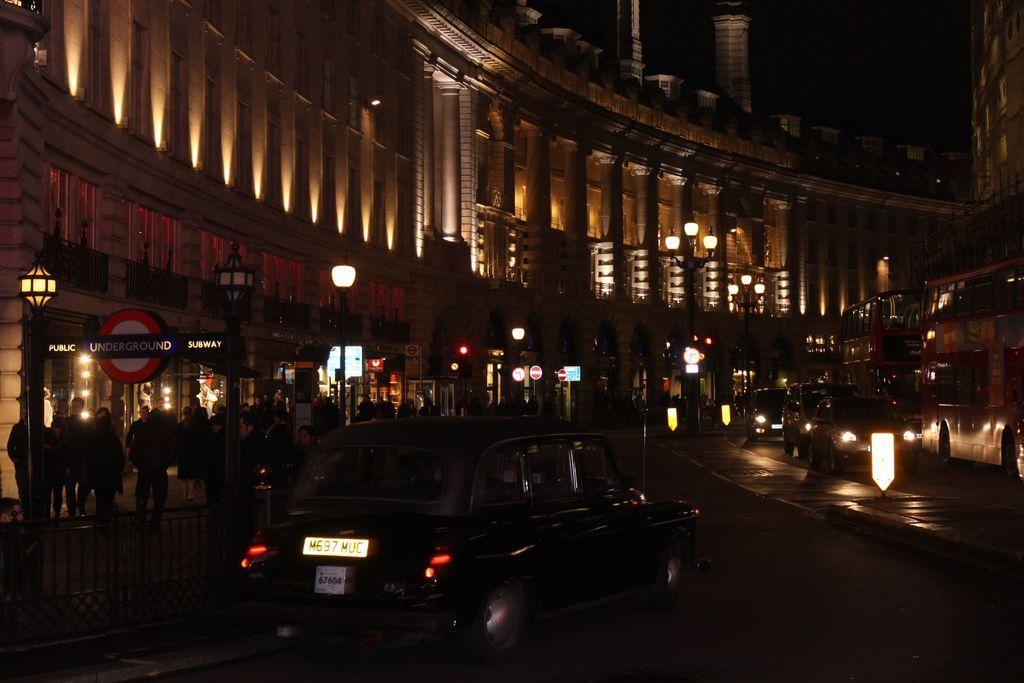Describe this image in one or two sentences. This picture is dark,we can see vehicles on the road,fence and people. In the background we can see lights and boards on poles and buildings. 